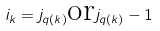<formula> <loc_0><loc_0><loc_500><loc_500>i _ { k } = j _ { q ( k ) } \text {or} j _ { q ( k ) } - 1</formula> 